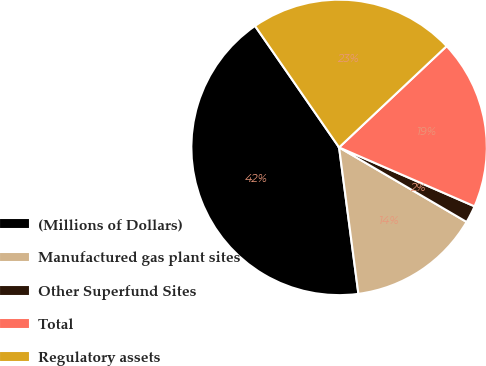Convert chart. <chart><loc_0><loc_0><loc_500><loc_500><pie_chart><fcel>(Millions of Dollars)<fcel>Manufactured gas plant sites<fcel>Other Superfund Sites<fcel>Total<fcel>Regulatory assets<nl><fcel>42.45%<fcel>14.49%<fcel>1.89%<fcel>18.55%<fcel>22.61%<nl></chart> 